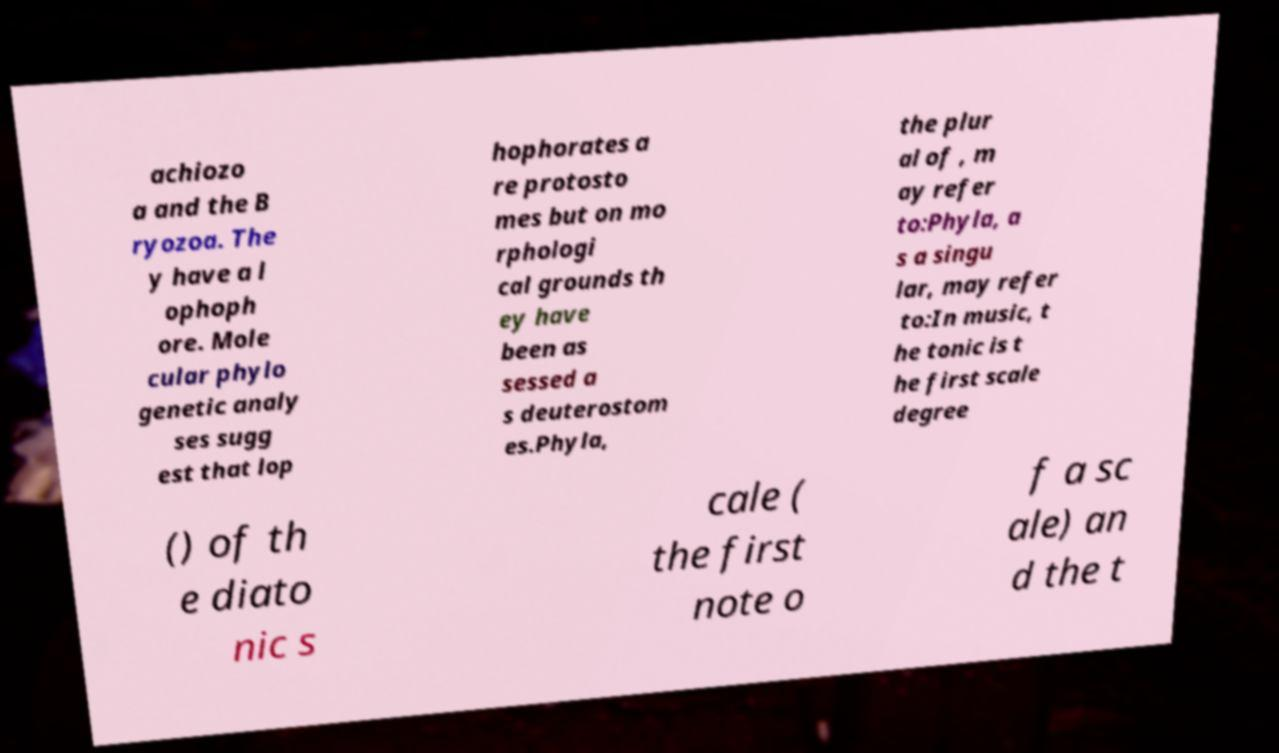Can you accurately transcribe the text from the provided image for me? achiozo a and the B ryozoa. The y have a l ophoph ore. Mole cular phylo genetic analy ses sugg est that lop hophorates a re protosto mes but on mo rphologi cal grounds th ey have been as sessed a s deuterostom es.Phyla, the plur al of , m ay refer to:Phyla, a s a singu lar, may refer to:In music, t he tonic is t he first scale degree () of th e diato nic s cale ( the first note o f a sc ale) an d the t 